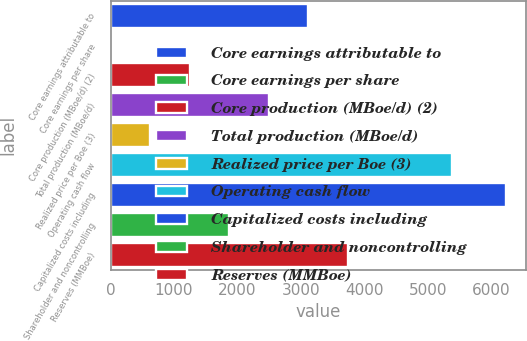Convert chart. <chart><loc_0><loc_0><loc_500><loc_500><bar_chart><fcel>Core earnings attributable to<fcel>Core earnings per share<fcel>Core production (MBoe/d) (2)<fcel>Total production (MBoe/d)<fcel>Realized price per Boe (3)<fcel>Operating cash flow<fcel>Capitalized costs including<fcel>Shareholder and noncontrolling<fcel>Reserves (MMBoe)<nl><fcel>3117.77<fcel>2.52<fcel>1248.62<fcel>2494.72<fcel>625.57<fcel>5383<fcel>6233<fcel>1871.67<fcel>3740.82<nl></chart> 